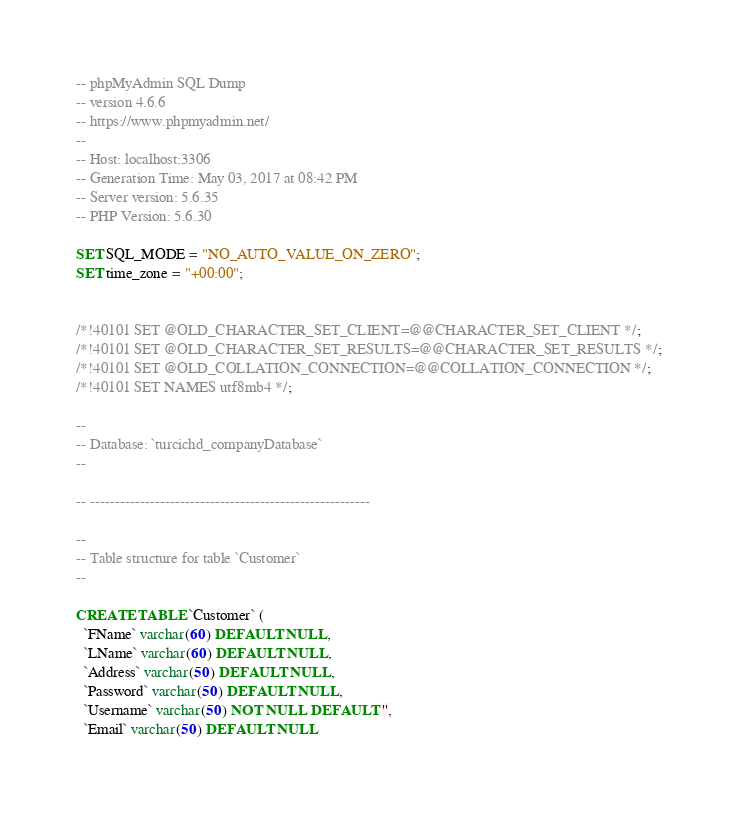<code> <loc_0><loc_0><loc_500><loc_500><_SQL_>-- phpMyAdmin SQL Dump
-- version 4.6.6
-- https://www.phpmyadmin.net/
--
-- Host: localhost:3306
-- Generation Time: May 03, 2017 at 08:42 PM
-- Server version: 5.6.35
-- PHP Version: 5.6.30

SET SQL_MODE = "NO_AUTO_VALUE_ON_ZERO";
SET time_zone = "+00:00";


/*!40101 SET @OLD_CHARACTER_SET_CLIENT=@@CHARACTER_SET_CLIENT */;
/*!40101 SET @OLD_CHARACTER_SET_RESULTS=@@CHARACTER_SET_RESULTS */;
/*!40101 SET @OLD_COLLATION_CONNECTION=@@COLLATION_CONNECTION */;
/*!40101 SET NAMES utf8mb4 */;

--
-- Database: `turcichd_companyDatabase`
--

-- --------------------------------------------------------

--
-- Table structure for table `Customer`
--

CREATE TABLE `Customer` (
  `FName` varchar(60) DEFAULT NULL,
  `LName` varchar(60) DEFAULT NULL,
  `Address` varchar(50) DEFAULT NULL,
  `Password` varchar(50) DEFAULT NULL,
  `Username` varchar(50) NOT NULL DEFAULT '',
  `Email` varchar(50) DEFAULT NULL</code> 